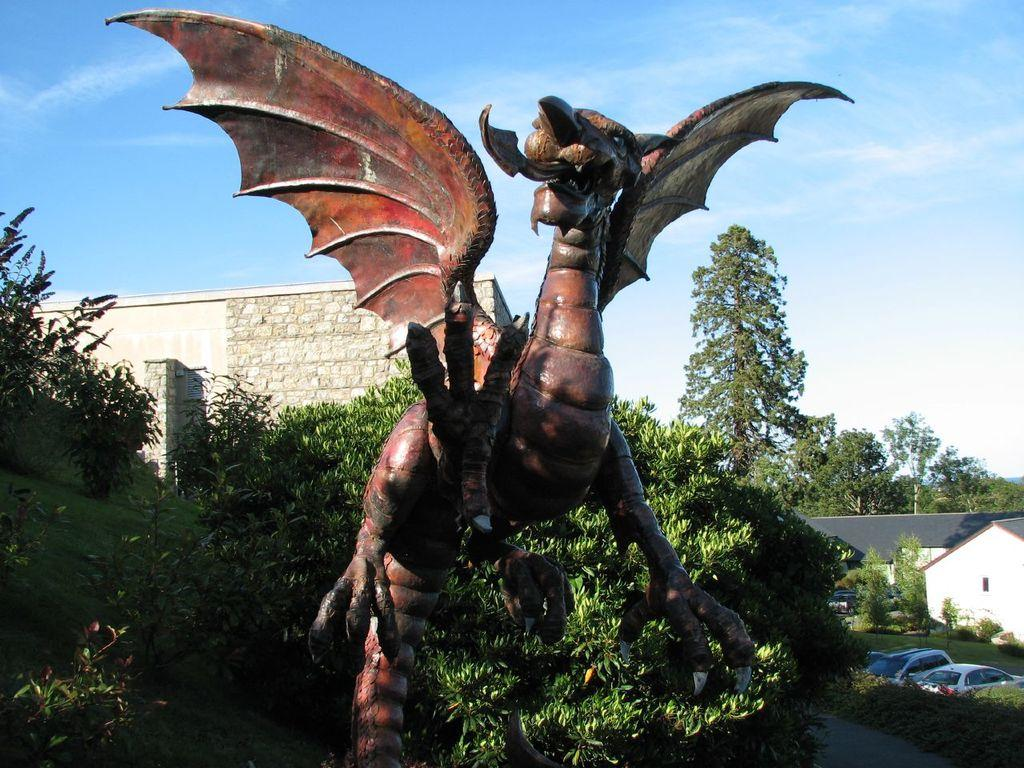What type of object is depicted as a statue in the image? There is an animal statue in the image. What other natural elements can be seen in the image? There are plants and trees in the image. What type of structure is visible in the image? There is a house in the image. What mode of transportation can be seen in the image? There are cars in the image. What part of the natural environment is visible in the image? The sky is visible in the image. What type of lunch is being served at the cemetery in the image? There is no cemetery or lunch present in the image. Can you compare the size of the animal statue to the trees in the image? The provided facts do not include any information about the size of the animal statue or the trees, so it is not possible to make a comparison. 